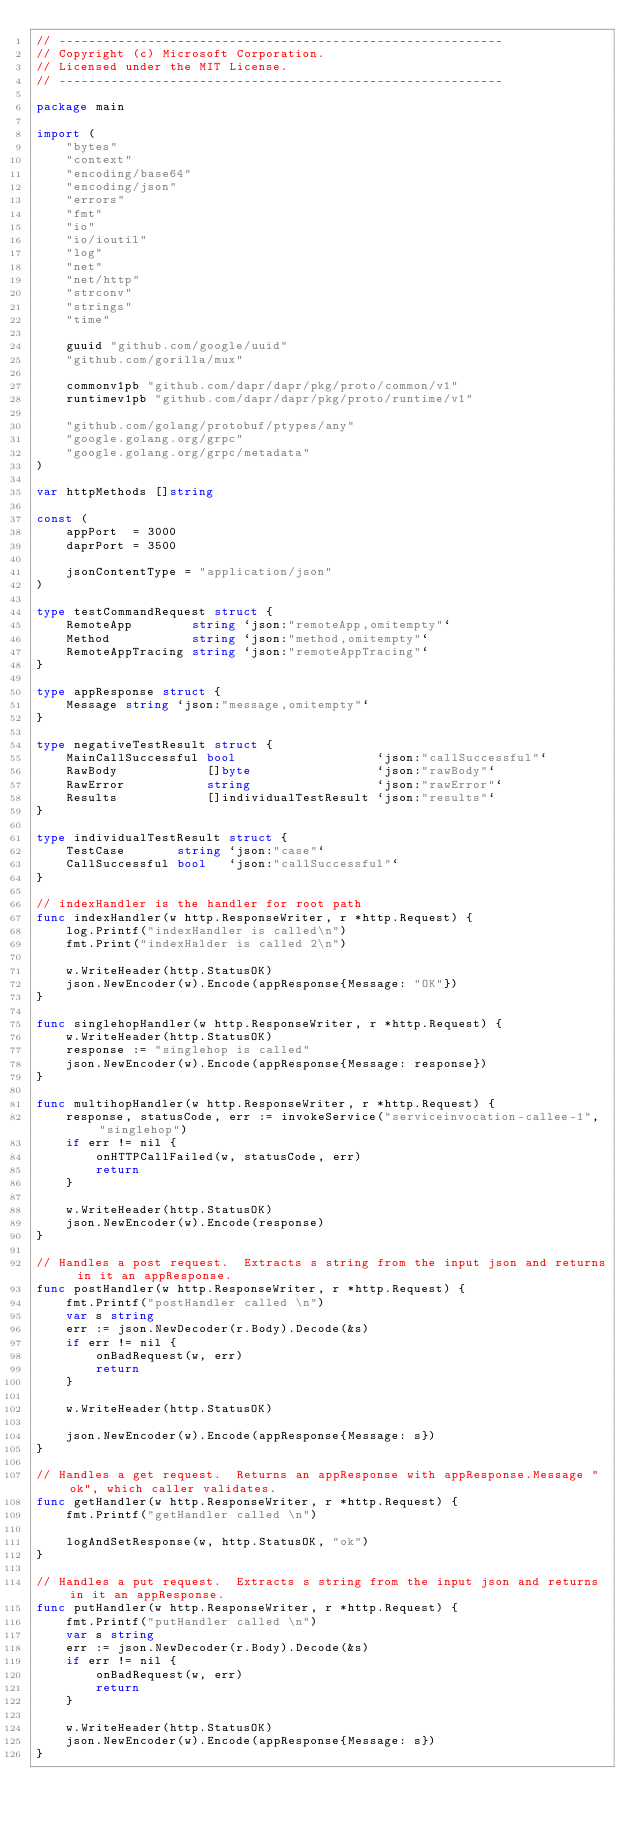Convert code to text. <code><loc_0><loc_0><loc_500><loc_500><_Go_>// ------------------------------------------------------------
// Copyright (c) Microsoft Corporation.
// Licensed under the MIT License.
// ------------------------------------------------------------

package main

import (
	"bytes"
	"context"
	"encoding/base64"
	"encoding/json"
	"errors"
	"fmt"
	"io"
	"io/ioutil"
	"log"
	"net"
	"net/http"
	"strconv"
	"strings"
	"time"

	guuid "github.com/google/uuid"
	"github.com/gorilla/mux"

	commonv1pb "github.com/dapr/dapr/pkg/proto/common/v1"
	runtimev1pb "github.com/dapr/dapr/pkg/proto/runtime/v1"

	"github.com/golang/protobuf/ptypes/any"
	"google.golang.org/grpc"
	"google.golang.org/grpc/metadata"
)

var httpMethods []string

const (
	appPort  = 3000
	daprPort = 3500

	jsonContentType = "application/json"
)

type testCommandRequest struct {
	RemoteApp        string `json:"remoteApp,omitempty"`
	Method           string `json:"method,omitempty"`
	RemoteAppTracing string `json:"remoteAppTracing"`
}

type appResponse struct {
	Message string `json:"message,omitempty"`
}

type negativeTestResult struct {
	MainCallSuccessful bool                   `json:"callSuccessful"`
	RawBody            []byte                 `json:"rawBody"`
	RawError           string                 `json:"rawError"`
	Results            []individualTestResult `json:"results"`
}

type individualTestResult struct {
	TestCase       string `json:"case"`
	CallSuccessful bool   `json:"callSuccessful"`
}

// indexHandler is the handler for root path
func indexHandler(w http.ResponseWriter, r *http.Request) {
	log.Printf("indexHandler is called\n")
	fmt.Print("indexHalder is called 2\n")

	w.WriteHeader(http.StatusOK)
	json.NewEncoder(w).Encode(appResponse{Message: "OK"})
}

func singlehopHandler(w http.ResponseWriter, r *http.Request) {
	w.WriteHeader(http.StatusOK)
	response := "singlehop is called"
	json.NewEncoder(w).Encode(appResponse{Message: response})
}

func multihopHandler(w http.ResponseWriter, r *http.Request) {
	response, statusCode, err := invokeService("serviceinvocation-callee-1", "singlehop")
	if err != nil {
		onHTTPCallFailed(w, statusCode, err)
		return
	}

	w.WriteHeader(http.StatusOK)
	json.NewEncoder(w).Encode(response)
}

// Handles a post request.  Extracts s string from the input json and returns in it an appResponse.
func postHandler(w http.ResponseWriter, r *http.Request) {
	fmt.Printf("postHandler called \n")
	var s string
	err := json.NewDecoder(r.Body).Decode(&s)
	if err != nil {
		onBadRequest(w, err)
		return
	}

	w.WriteHeader(http.StatusOK)

	json.NewEncoder(w).Encode(appResponse{Message: s})
}

// Handles a get request.  Returns an appResponse with appResponse.Message "ok", which caller validates.
func getHandler(w http.ResponseWriter, r *http.Request) {
	fmt.Printf("getHandler called \n")

	logAndSetResponse(w, http.StatusOK, "ok")
}

// Handles a put request.  Extracts s string from the input json and returns in it an appResponse.
func putHandler(w http.ResponseWriter, r *http.Request) {
	fmt.Printf("putHandler called \n")
	var s string
	err := json.NewDecoder(r.Body).Decode(&s)
	if err != nil {
		onBadRequest(w, err)
		return
	}

	w.WriteHeader(http.StatusOK)
	json.NewEncoder(w).Encode(appResponse{Message: s})
}
</code> 